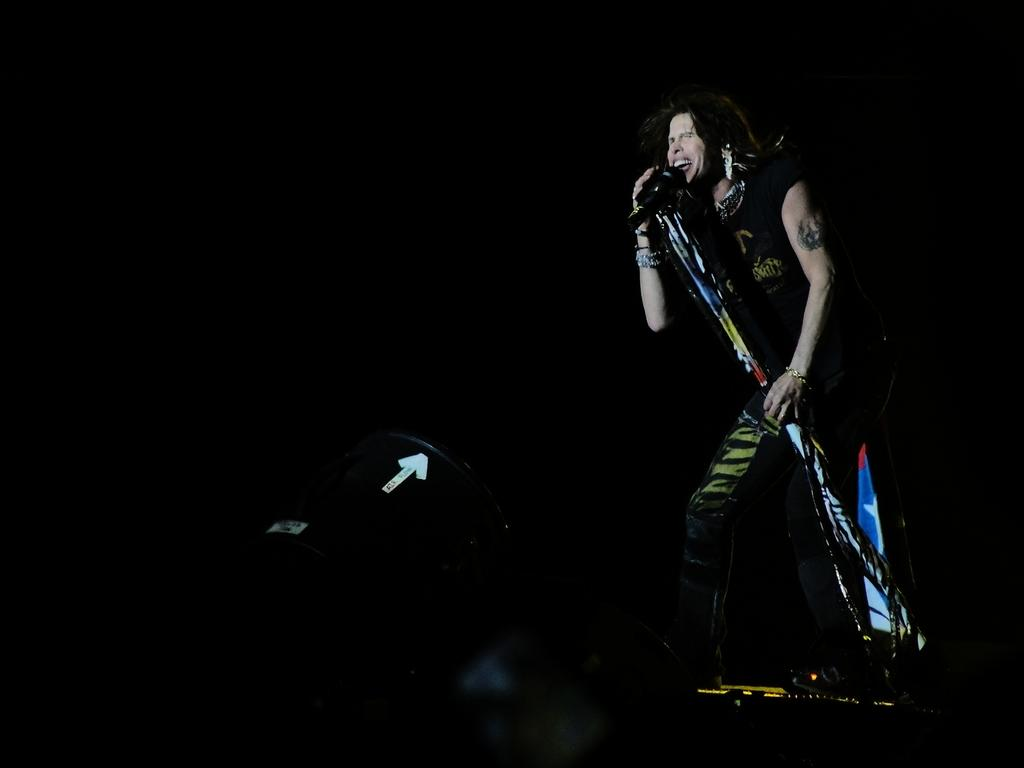What is the person in the image doing? The person is singing in the image. What is the person holding while singing? The person is holding a microphone. What musical instrument can be seen in the image? There is a musical drum in the image. What is the color of the background in the image? The background of the image is dark. What type of picture is hanging on the wall in the image? There is no mention of a picture hanging on the wall in the image. Can you tell me how many oranges are on the table in the image? There is no mention of oranges or a table in the image. Is there any popcorn visible in the image? There is no mention of popcorn in the image. 